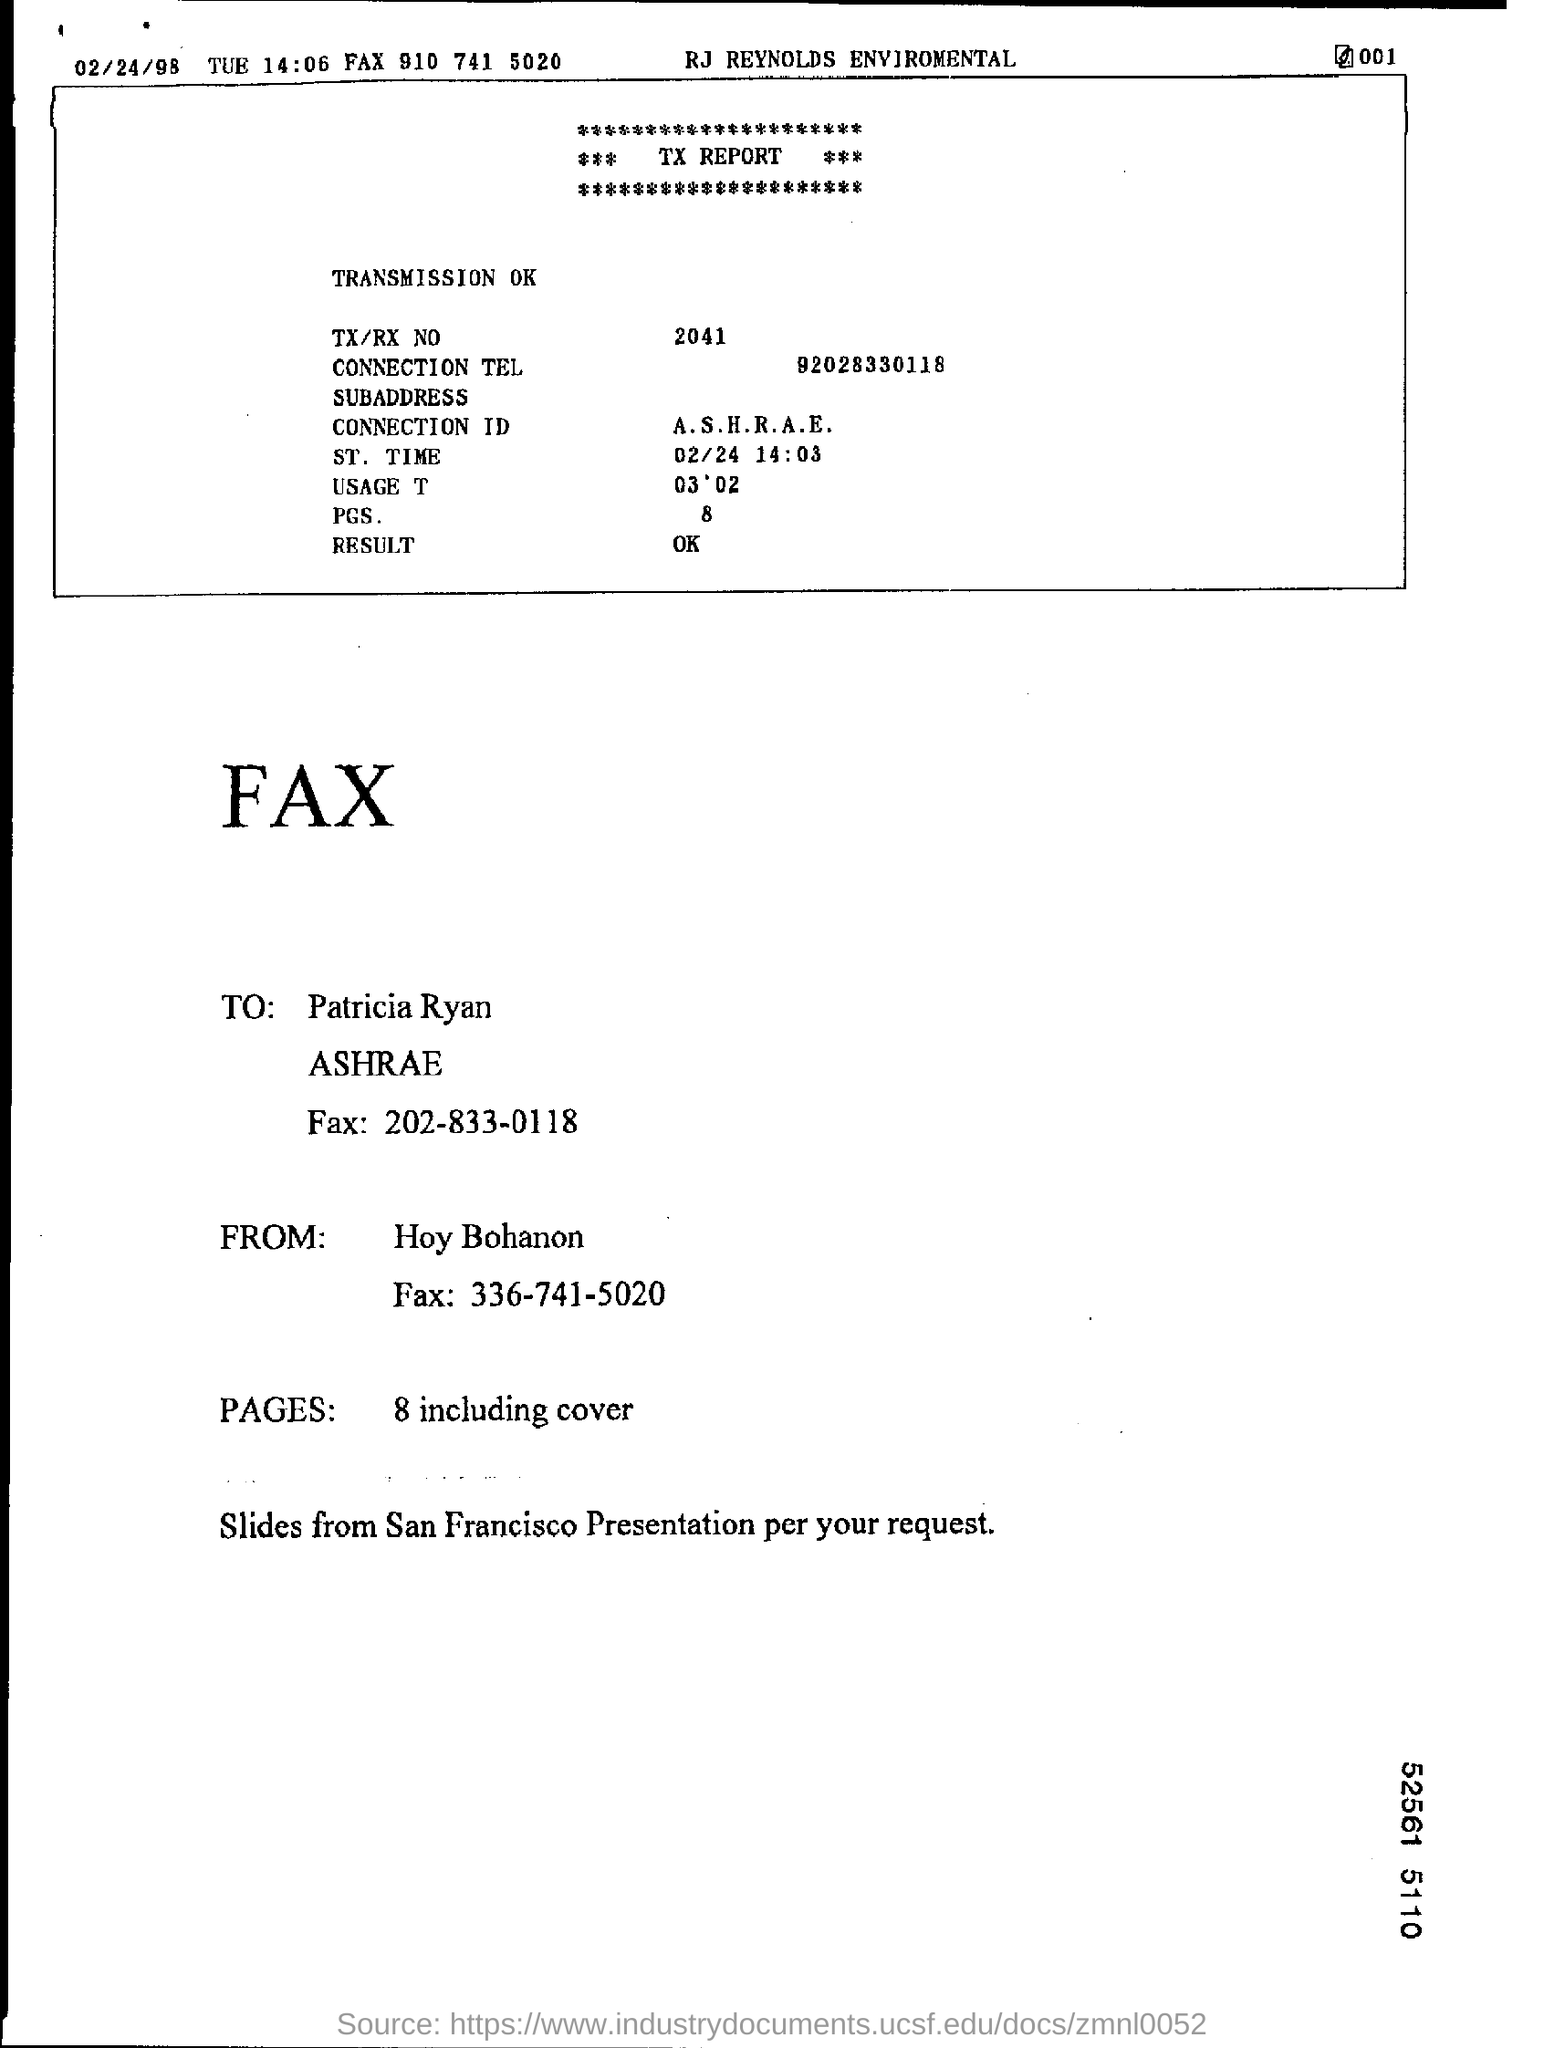Can you tell me to whom the fax was addressed and who sent it? The fax was addressed to Patricia Ryan at ASHRAE with the fax number 202-833-0118. It was sent from Hoy Bohanon, with the sender's fax number being 336-741-5020. 